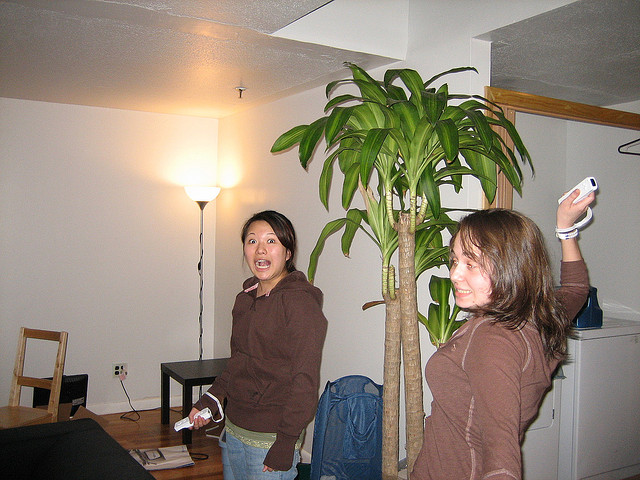<image>Where are the flowers? There are no flowers in the image. However, if present they might be between people or in a vase. Where are the flowers? It is unknown where the flowers are. There are no flowers in the image. 